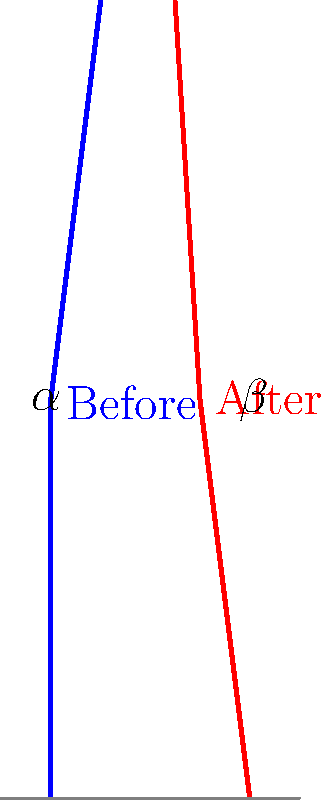The silhouette diagram shows the posture of an individual before and after undergoing rehabilitation techniques. The blue line represents the initial posture, while the red line shows the improved posture. If the angle between the vertical and the spine before treatment is $\alpha = 15°$, and after treatment is $\beta = 5°$, what is the angle of improvement in degrees? To calculate the angle of improvement, we need to follow these steps:

1) First, we identify the initial angle ($\alpha$) and the final angle ($\beta$):
   Initial angle $\alpha = 15°$
   Final angle $\beta = 5°$

2) The angle of improvement is the difference between the initial and final angles:
   Angle of improvement = Initial angle - Final angle
   
3) Substituting the values:
   Angle of improvement = $\alpha - \beta = 15° - 5°$

4) Calculating the difference:
   Angle of improvement = $10°$

Therefore, the angle of improvement in the individual's posture is 10 degrees.
Answer: $10°$ 